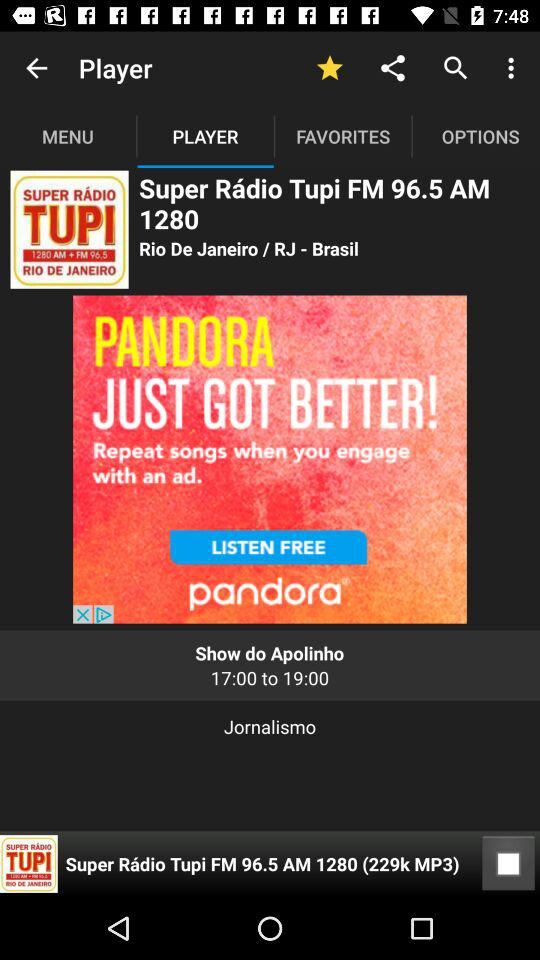Which tab is selected? The selected tab is "PLAYER". 